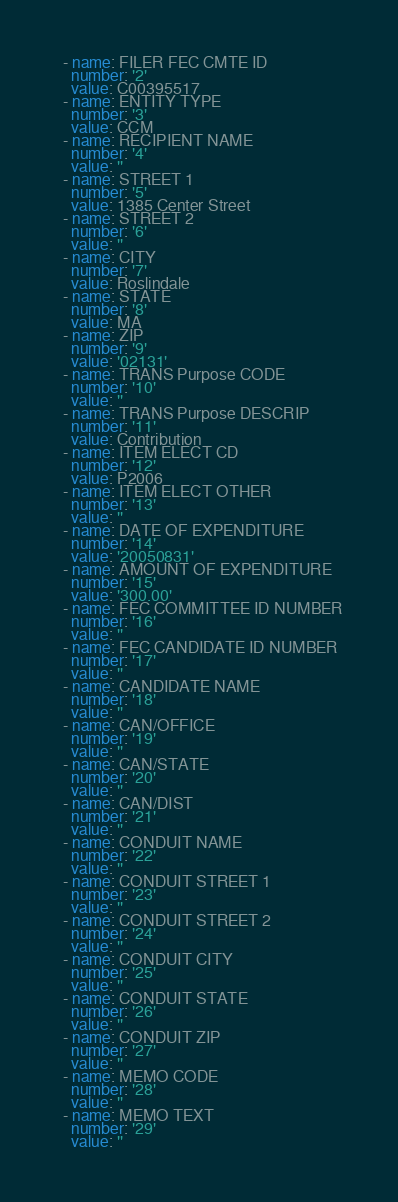<code> <loc_0><loc_0><loc_500><loc_500><_YAML_>  - name: FILER FEC CMTE ID
    number: '2'
    value: C00395517
  - name: ENTITY TYPE
    number: '3'
    value: CCM
  - name: RECIPIENT NAME
    number: '4'
    value: ''
  - name: STREET 1
    number: '5'
    value: 1385 Center Street
  - name: STREET 2
    number: '6'
    value: ''
  - name: CITY
    number: '7'
    value: Roslindale
  - name: STATE
    number: '8'
    value: MA
  - name: ZIP
    number: '9'
    value: '02131'
  - name: TRANS Purpose CODE
    number: '10'
    value: ''
  - name: TRANS Purpose DESCRIP
    number: '11'
    value: Contribution
  - name: ITEM ELECT CD
    number: '12'
    value: P2006
  - name: ITEM ELECT OTHER
    number: '13'
    value: ''
  - name: DATE OF EXPENDITURE
    number: '14'
    value: '20050831'
  - name: AMOUNT OF EXPENDITURE
    number: '15'
    value: '300.00'
  - name: FEC COMMITTEE ID NUMBER
    number: '16'
    value: ''
  - name: FEC CANDIDATE ID NUMBER
    number: '17'
    value: ''
  - name: CANDIDATE NAME
    number: '18'
    value: ''
  - name: CAN/OFFICE
    number: '19'
    value: ''
  - name: CAN/STATE
    number: '20'
    value: ''
  - name: CAN/DIST
    number: '21'
    value: ''
  - name: CONDUIT NAME
    number: '22'
    value: ''
  - name: CONDUIT STREET 1
    number: '23'
    value: ''
  - name: CONDUIT STREET 2
    number: '24'
    value: ''
  - name: CONDUIT CITY
    number: '25'
    value: ''
  - name: CONDUIT STATE
    number: '26'
    value: ''
  - name: CONDUIT ZIP
    number: '27'
    value: ''
  - name: MEMO CODE
    number: '28'
    value: ''
  - name: MEMO TEXT
    number: '29'
    value: ''</code> 